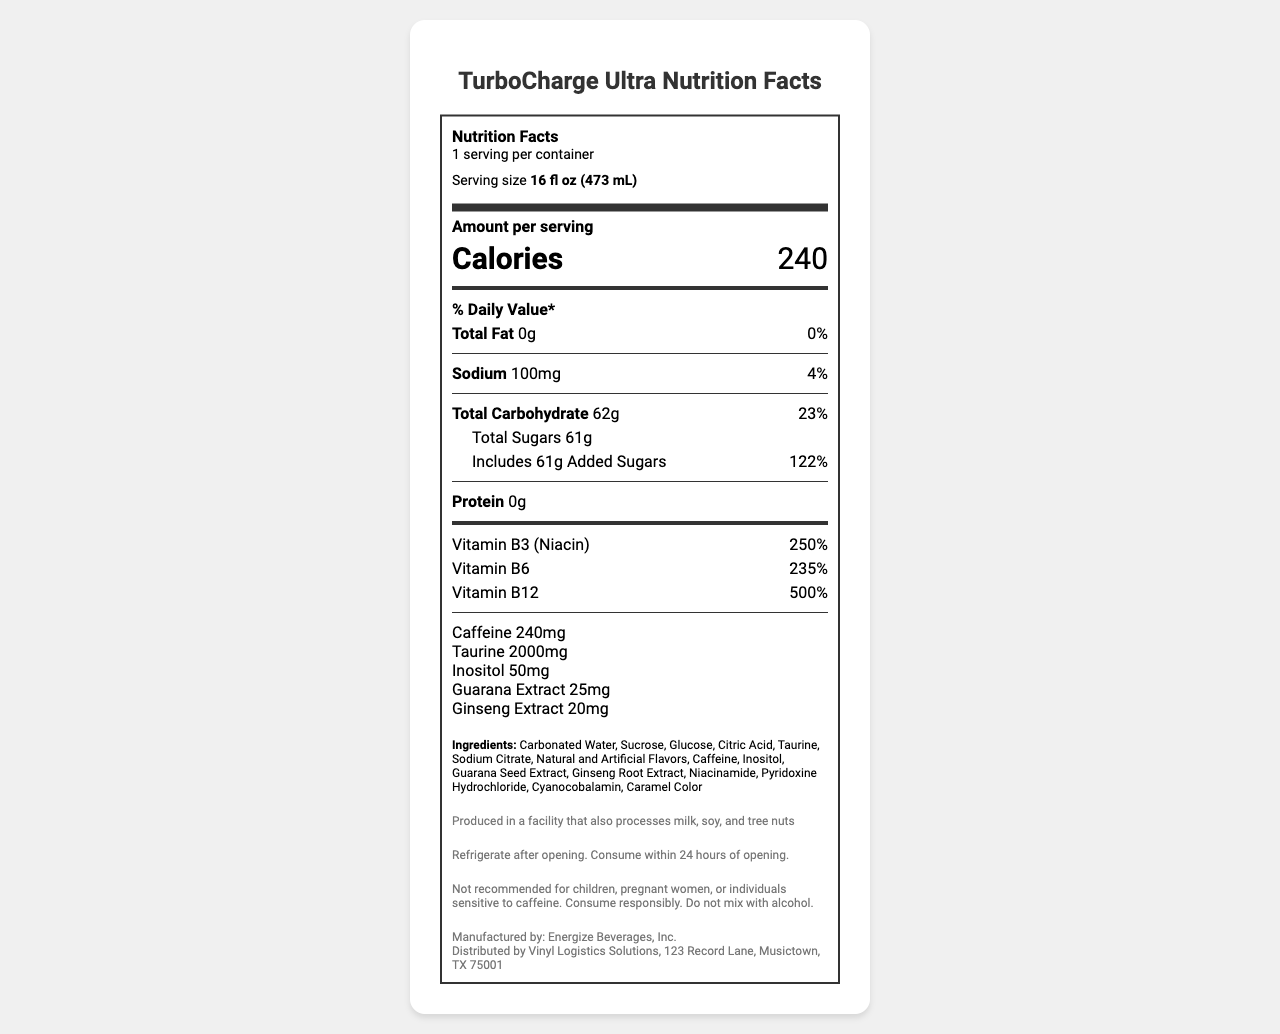what is the serving size of TurboCharge Ultra? The serving size is listed under the serving information as "16 fl oz (473 mL)".
Answer: 16 fl oz (473 mL) how many calories are in one serving of TurboCharge Ultra? The document states that each serving contains 240 calories.
Answer: 240 how much caffeine is in TurboCharge Ultra? The caffeine content is directly listed as 240mg.
Answer: 240mg what is the daily value percentage for Vitamin B12 in TurboCharge Ultra? The daily value percentage for Vitamin B12 is given as 500%.
Answer: 500% list three ingredients found in TurboCharge Ultra. The ingredients list includes Carbonated Water, Sucrose, and Glucose among others.
Answer: Carbonated Water, Sucrose, Glucose what is the total fat content in TurboCharge Ultra? The document reveals that TurboCharge Ultra contains 0g of total fat.
Answer: 0g what allergen information is provided for TurboCharge Ultra? The allergen information is clearly stated at the end of the document.
Answer: Produced in a facility that also processes milk, soy, and tree nuts who distributes TurboCharge Ultra? The distribution info at the bottom of the document mentions that it is distributed by Vinyl Logistics Solutions.
Answer: Vinyl Logistics Solutions how should TurboCharge Ultra be stored after opening? The storage instructions state to refrigerate after opening and consume within 24 hours.
Answer: Refrigerate after opening. Consume within 24 hours of opening. which vitamin has the highest daily value percentage in TurboCharge Ultra? (A. Vitamin B3 B. Vitamin B6 C. Vitamin B12) The daily value percentages listed are Vitamin B3 (250%), Vitamin B6 (235%), and Vitamin B12 (500%). Vitamin B12 has the highest percentage.
Answer: C. Vitamin B12 which of the following is NOT an ingredient in TurboCharge Ultra? (A. Caramel Color B. Taurine C. Ascorbic Acid) The ingredients list includes Caramel Color and Taurine but not Ascorbic Acid.
Answer: C. Ascorbic Acid does TurboCharge Ultra contain any protein? The document specifies that the protein content is 0g.
Answer: No should TurboCharge Ultra be mixed with alcohol? The disclaimer advises against mixing the drink with alcohol.
Answer: No summarize the main information provided in the document. The document comprehensively details the nutrition facts, ingredients, and other critical information related to TurboCharge Ultra, including safety and consumption guidelines.
Answer: The document provides the nutrition facts for TurboCharge Ultra, an energy drink. It specifies serving size, calories, nutrients, vitamins, and ingredients. It also includes allergen and storage instructions, manufacturer and distribution details, and various disclaimers. what is the caffeine amount per 100mL of TurboCharge Ultra? The document provides the caffeine amount per 16 fl oz (473 mL) serving but does not specify the amount per 100mL.
Answer: Not enough information 